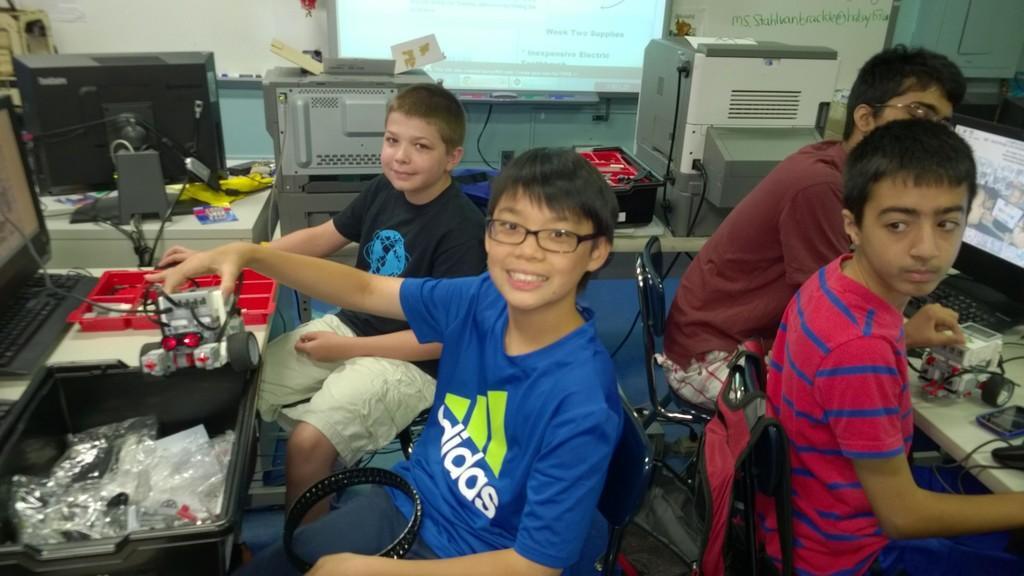Could you give a brief overview of what you see in this image? This image consists of computers. There are 4 boys who are sitting on chairs. This looks like they are preparing motor car. 